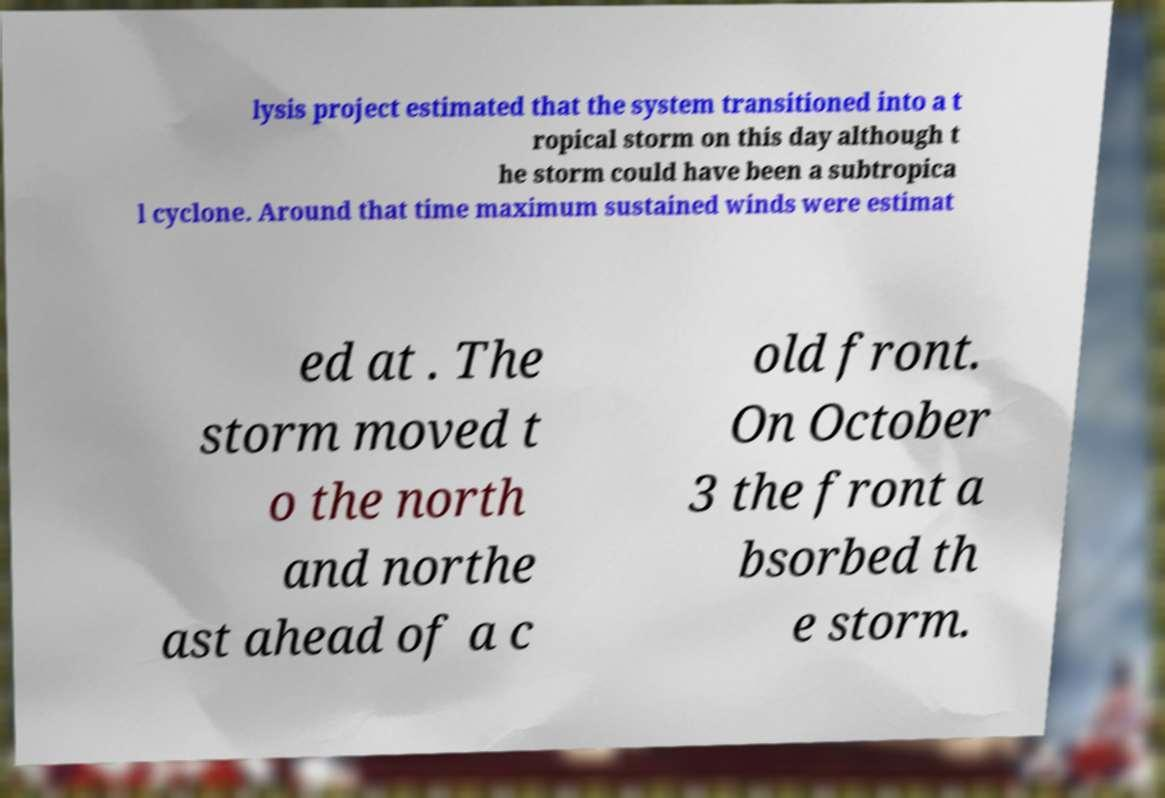I need the written content from this picture converted into text. Can you do that? lysis project estimated that the system transitioned into a t ropical storm on this day although t he storm could have been a subtropica l cyclone. Around that time maximum sustained winds were estimat ed at . The storm moved t o the north and northe ast ahead of a c old front. On October 3 the front a bsorbed th e storm. 